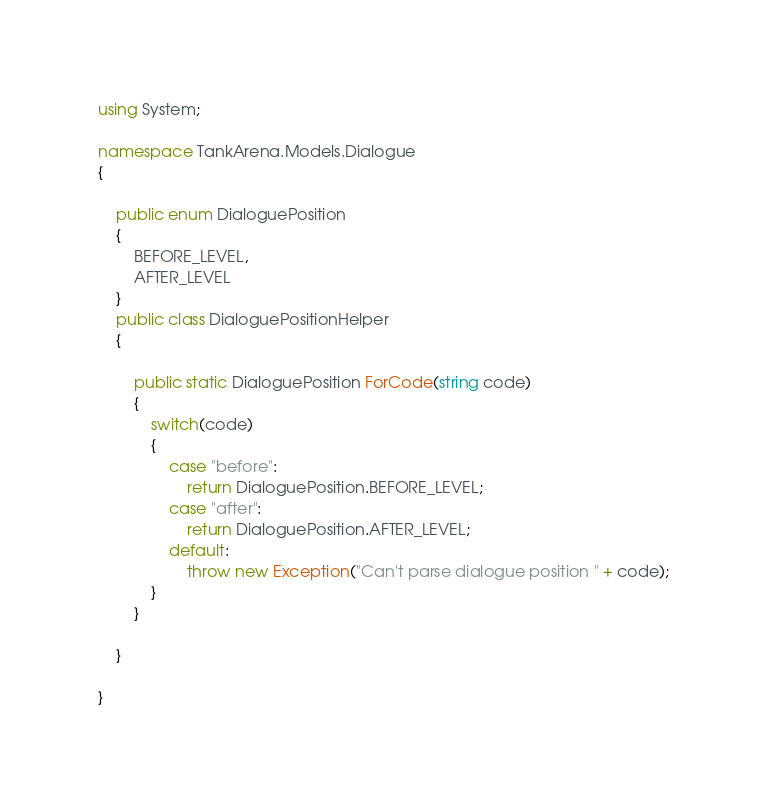Convert code to text. <code><loc_0><loc_0><loc_500><loc_500><_C#_>using System;

namespace TankArena.Models.Dialogue
{

    public enum DialoguePosition
    {
        BEFORE_LEVEL,
        AFTER_LEVEL
    }
    public class DialoguePositionHelper
    {

        public static DialoguePosition ForCode(string code)
        {
            switch(code)
            {
                case "before":
                    return DialoguePosition.BEFORE_LEVEL;
                case "after":
                    return DialoguePosition.AFTER_LEVEL;
                default:
                    throw new Exception("Can't parse dialogue position " + code);
            }
        }

    }

}</code> 